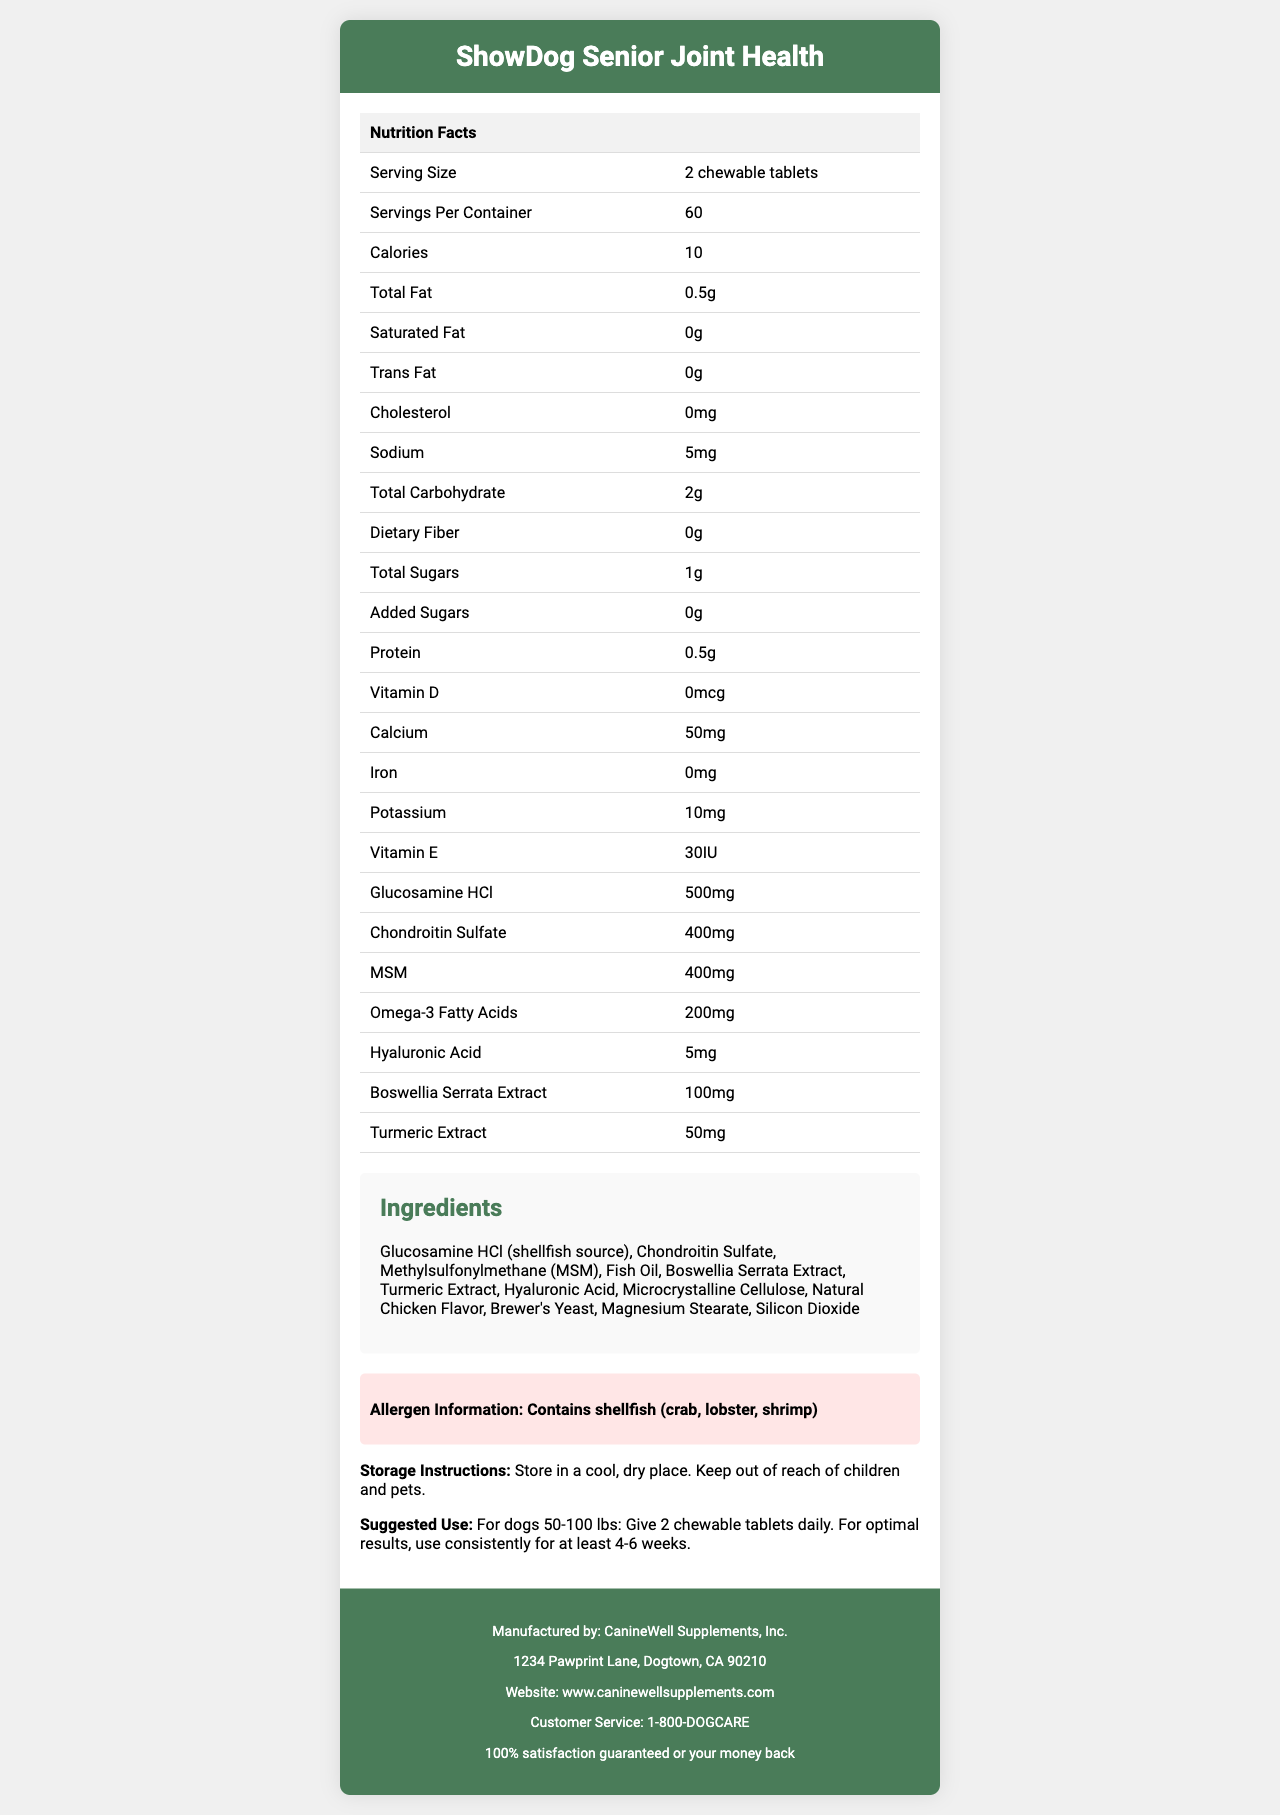what is the serving size? The serving size is clearly listed in the Nutrition Facts section as "2 chewable tablets".
Answer: 2 chewable tablets how many servings are there per container? The document specifies that there are 60 servings per container.
Answer: 60 servings how many calories are in each serving? The label states that each serving contains 10 calories.
Answer: 10 calories what is the total amount of fat per serving? According to the Nutrition Facts, each serving contains 0.5 grams of total fat.
Answer: 0.5g how much glucosamine HCl is in each serving? The document lists 500mg of glucosamine HCl per serving.
Answer: 500mg which ingredient is a common allergen present in the supplement? The allergen information explicitly mentions that the supplement contains shellfish (crab, lobster, shrimp).
Answer: Shellfish how much chondroitin sulfate does each serving have? The serving contains 400mg of chondroitin sulfate, as stated in the Nutrition Facts.
Answer: 400mg who manufactures the "ShowDog Senior Joint Health" supplement? The footer of the document indicates that CanineWell Supplements, Inc. manufactures the product.
Answer: CanineWell Supplements, Inc. what is the suggested use for a 60-pound dog? The suggested use section specifies that for dogs 50-100 lbs, 2 chewable tablets should be given daily.
Answer: Give 2 chewable tablets daily which of the following ingredients is NOT listed in the supplement? 
A. Turmeric Extract 
B. Brewer's Yeast 
C. Vitamin C 
D. Fish Oil The ingredient list includes Turmeric Extract, Brewer's Yeast, and Fish Oil but does not mention Vitamin C.
Answer: C. Vitamin C how much calcium is in each serving? The label states that each serving contains 50mg of calcium.
Answer: 50mg how long should the supplement be used for optimal results? 
A. 2-4 weeks 
B. 4-6 weeks 
C. 6-8 weeks 
D. At least 8 weeks The suggested use section advises to use the supplement consistently for at least 4-6 weeks for optimal results.
Answer: B. 4-6 weeks does the supplement include any added sugars? The label specifies 0g of added sugars in each serving.
Answer: No is it safe to store the supplement in a humid place? The storage instructions recommend storing the supplement in a cool, dry place.
Answer: No where should the supplement be stored? The storage instructions advise storing the supplement in a cool, dry place.
Answer: In a cool, dry place summarize the main idea of the document. The document's primary focus is to offer comprehensive information about the "ShowDog Senior Joint Health" supplement, facilitating better understanding and proper usage to support joint health in retired show dogs.
Answer: The document provides detailed nutrition facts and usage information for the "ShowDog Senior Joint Health" supplement, including serving size, nutritional content, ingredient list, allergen information, storage instructions, and manufacturer details. how is the product consumed? The document does not specify how the chewable tablets should be consumed (e.g., mixed with food or given as treats), so the information cannot be determined.
Answer: Cannot be determined 